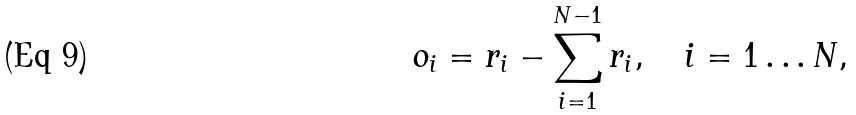Convert formula to latex. <formula><loc_0><loc_0><loc_500><loc_500>o _ { i } = r _ { i } - \sum _ { i = 1 } ^ { N - 1 } r _ { i } , \quad i = 1 \dots N ,</formula> 